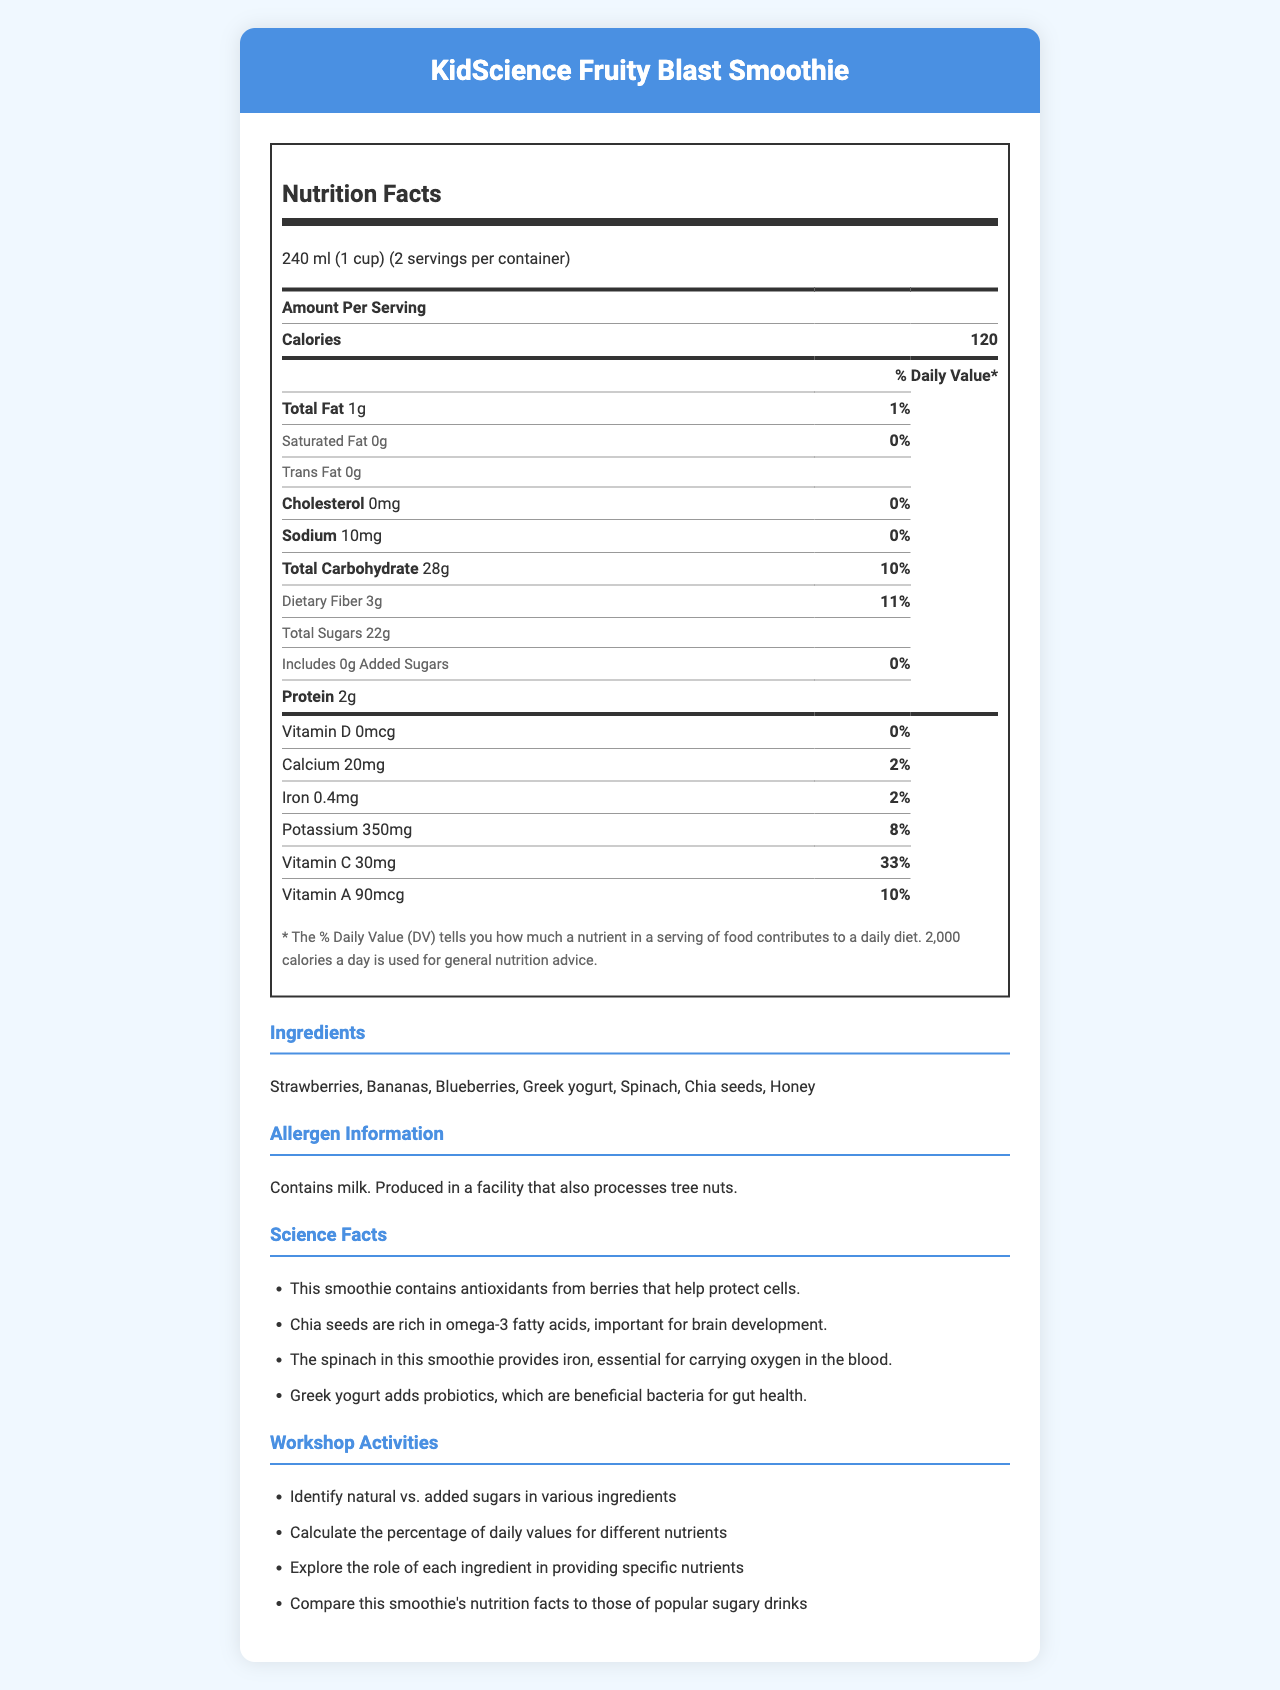what is the serving size of the KidScience Fruity Blast Smoothie? The serving size is clearly listed at the beginning of the Nutrition Facts section.
Answer: 240 ml (1 cup) how many servings are in one container? The servings per container is mentioned right after the serving size.
Answer: 2 how many grams of dietary fiber are in a serving of the smoothie? The amount of dietary fiber per serving is listed as 3 grams in the Total Carbohydrate section.
Answer: 3 grams does the smoothie contain any added sugars? The Amount of added sugars is listed as 0 grams.
Answer: No what is the main allergen mentioned in the document? The Allergen Information section states that the smoothie contains milk.
Answer: Milk what is the percentage of daily value of Vitamin C provided by one serving of the smoothie? The % Daily Value for Vitamin C is listed as 33%.
Answer: 33% how much potassium is in a serving of the smoothie? A. 100 mg B. 250 mg C. 350 mg D. 450 mg The Nutrition Facts section lists potassium as 350 mg per serving.
Answer: C. 350 mg which ingredient is NOT in the KidScience Fruity Blast Smoothie? A. Mango B. Spinach C. Blueberries D. Greek Yogurt The listed ingredients include Spinach, Blueberries, and Greek Yogurt but do not include Mango.
Answer: A. Mango does the smoothie contain any cholesterol? The amount of cholesterol per serving is listed as 0 mg, indicating there is no cholesterol.
Answer: No describe the main nutritional highlights of this document. The document summarizes the key nutritional elements in the smoothie, emphasizing its health benefits.
Answer: The KidScience Fruity Blast Smoothie provides a detailed breakdown of nutrients in each serving, highlighting its low calorie and fat content, while being rich in carbohydrates, dietary fiber, potassium, and vitamins A and C. It contains no added sugars or cholesterol and includes ingredients like strawberries, blueberries, and Greek yogurt, which contribute to its nutrient values. what are omega-3 fatty acids? The document provides some science facts but does not explain omega-3 fatty acids directly. It just mentions that chia seeds are rich in them.
Answer: Cannot be determined 